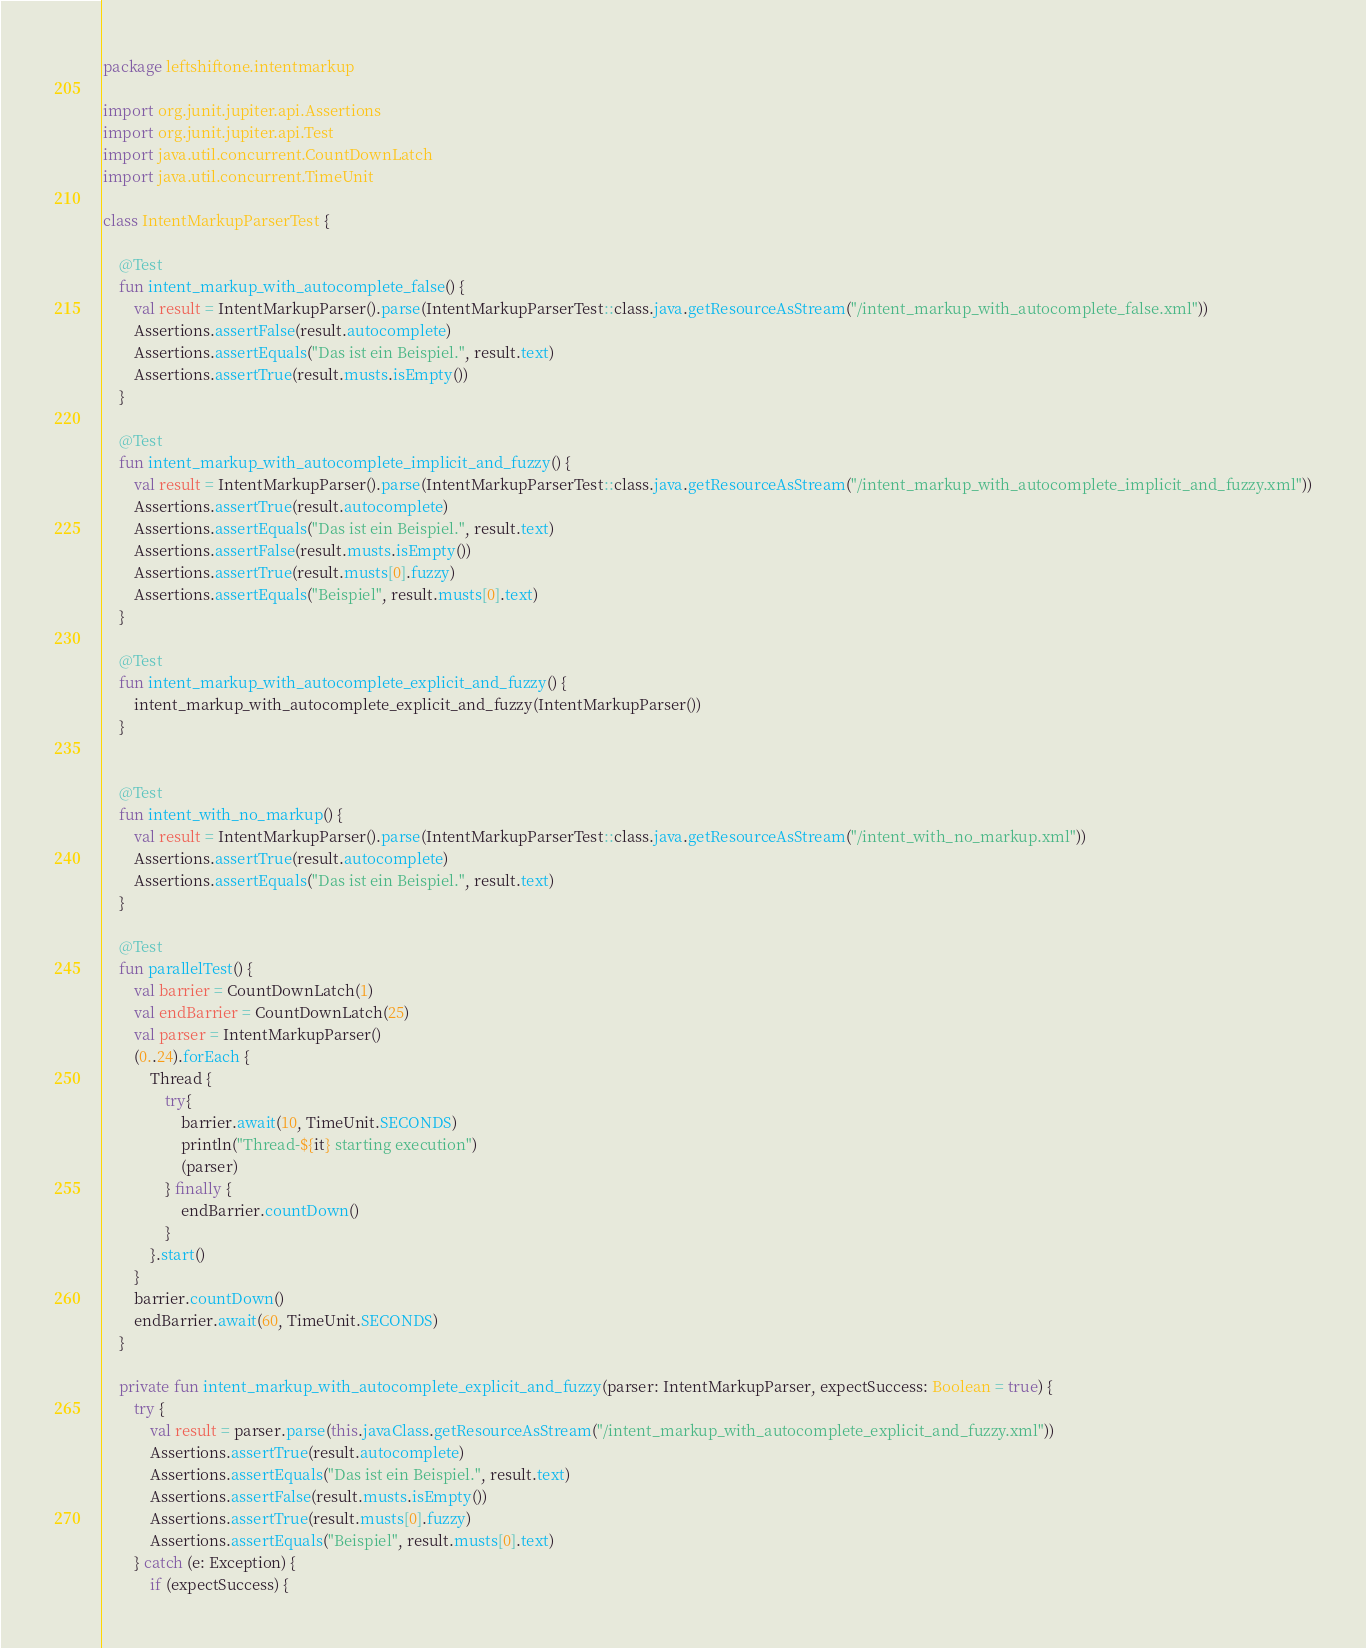<code> <loc_0><loc_0><loc_500><loc_500><_Kotlin_>package leftshiftone.intentmarkup

import org.junit.jupiter.api.Assertions
import org.junit.jupiter.api.Test
import java.util.concurrent.CountDownLatch
import java.util.concurrent.TimeUnit

class IntentMarkupParserTest {

    @Test
    fun intent_markup_with_autocomplete_false() {
        val result = IntentMarkupParser().parse(IntentMarkupParserTest::class.java.getResourceAsStream("/intent_markup_with_autocomplete_false.xml"))
        Assertions.assertFalse(result.autocomplete)
        Assertions.assertEquals("Das ist ein Beispiel.", result.text)
        Assertions.assertTrue(result.musts.isEmpty())
    }

    @Test
    fun intent_markup_with_autocomplete_implicit_and_fuzzy() {
        val result = IntentMarkupParser().parse(IntentMarkupParserTest::class.java.getResourceAsStream("/intent_markup_with_autocomplete_implicit_and_fuzzy.xml"))
        Assertions.assertTrue(result.autocomplete)
        Assertions.assertEquals("Das ist ein Beispiel.", result.text)
        Assertions.assertFalse(result.musts.isEmpty())
        Assertions.assertTrue(result.musts[0].fuzzy)
        Assertions.assertEquals("Beispiel", result.musts[0].text)
    }

    @Test
    fun intent_markup_with_autocomplete_explicit_and_fuzzy() {
        intent_markup_with_autocomplete_explicit_and_fuzzy(IntentMarkupParser())
    }


    @Test
    fun intent_with_no_markup() {
        val result = IntentMarkupParser().parse(IntentMarkupParserTest::class.java.getResourceAsStream("/intent_with_no_markup.xml"))
        Assertions.assertTrue(result.autocomplete)
        Assertions.assertEquals("Das ist ein Beispiel.", result.text)
    }

    @Test
    fun parallelTest() {
        val barrier = CountDownLatch(1)
        val endBarrier = CountDownLatch(25)
        val parser = IntentMarkupParser()
        (0..24).forEach {
            Thread {
                try{
                    barrier.await(10, TimeUnit.SECONDS)
                    println("Thread-${it} starting execution")
                    (parser)
                } finally {
                    endBarrier.countDown()
                }
            }.start()
        }
        barrier.countDown()
        endBarrier.await(60, TimeUnit.SECONDS)
    }

    private fun intent_markup_with_autocomplete_explicit_and_fuzzy(parser: IntentMarkupParser, expectSuccess: Boolean = true) {
        try {
            val result = parser.parse(this.javaClass.getResourceAsStream("/intent_markup_with_autocomplete_explicit_and_fuzzy.xml"))
            Assertions.assertTrue(result.autocomplete)
            Assertions.assertEquals("Das ist ein Beispiel.", result.text)
            Assertions.assertFalse(result.musts.isEmpty())
            Assertions.assertTrue(result.musts[0].fuzzy)
            Assertions.assertEquals("Beispiel", result.musts[0].text)
        } catch (e: Exception) {
            if (expectSuccess) {</code> 